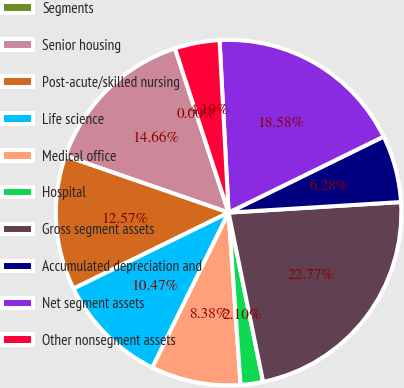Convert chart. <chart><loc_0><loc_0><loc_500><loc_500><pie_chart><fcel>Segments<fcel>Senior housing<fcel>Post-acute/skilled nursing<fcel>Life science<fcel>Medical office<fcel>Hospital<fcel>Gross segment assets<fcel>Accumulated depreciation and<fcel>Net segment assets<fcel>Other nonsegment assets<nl><fcel>0.0%<fcel>14.66%<fcel>12.57%<fcel>10.47%<fcel>8.38%<fcel>2.1%<fcel>22.77%<fcel>6.28%<fcel>18.58%<fcel>4.19%<nl></chart> 